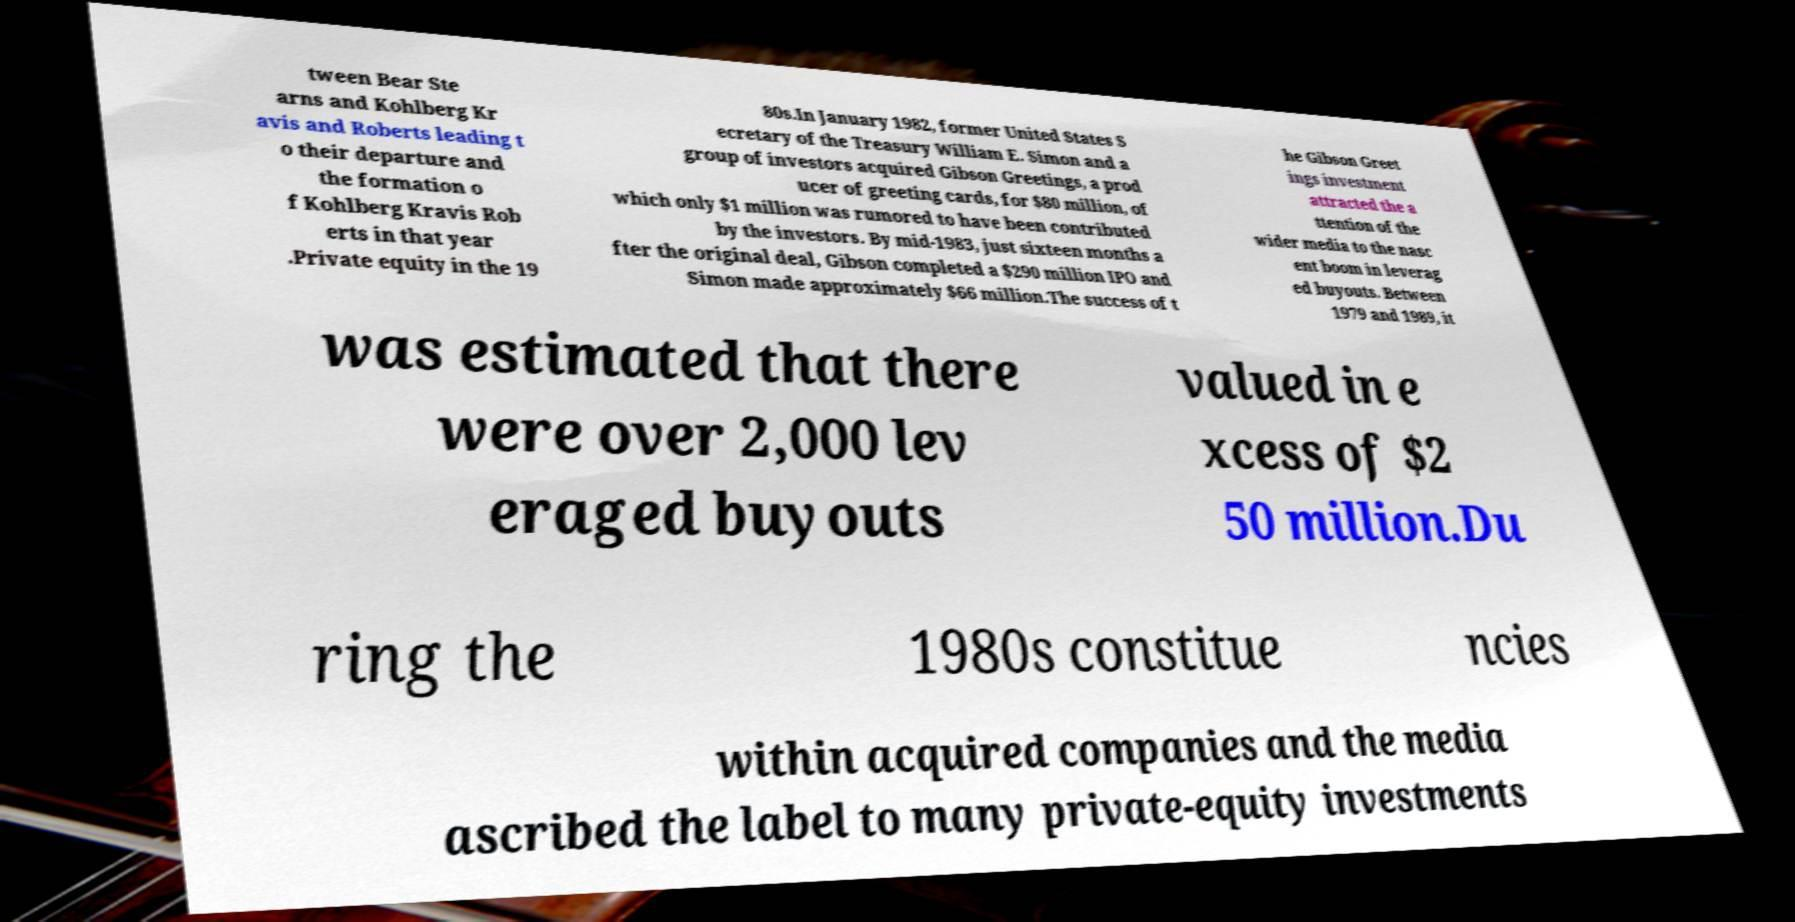For documentation purposes, I need the text within this image transcribed. Could you provide that? tween Bear Ste arns and Kohlberg Kr avis and Roberts leading t o their departure and the formation o f Kohlberg Kravis Rob erts in that year .Private equity in the 19 80s.In January 1982, former United States S ecretary of the Treasury William E. Simon and a group of investors acquired Gibson Greetings, a prod ucer of greeting cards, for $80 million, of which only $1 million was rumored to have been contributed by the investors. By mid-1983, just sixteen months a fter the original deal, Gibson completed a $290 million IPO and Simon made approximately $66 million.The success of t he Gibson Greet ings investment attracted the a ttention of the wider media to the nasc ent boom in leverag ed buyouts. Between 1979 and 1989, it was estimated that there were over 2,000 lev eraged buyouts valued in e xcess of $2 50 million.Du ring the 1980s constitue ncies within acquired companies and the media ascribed the label to many private-equity investments 